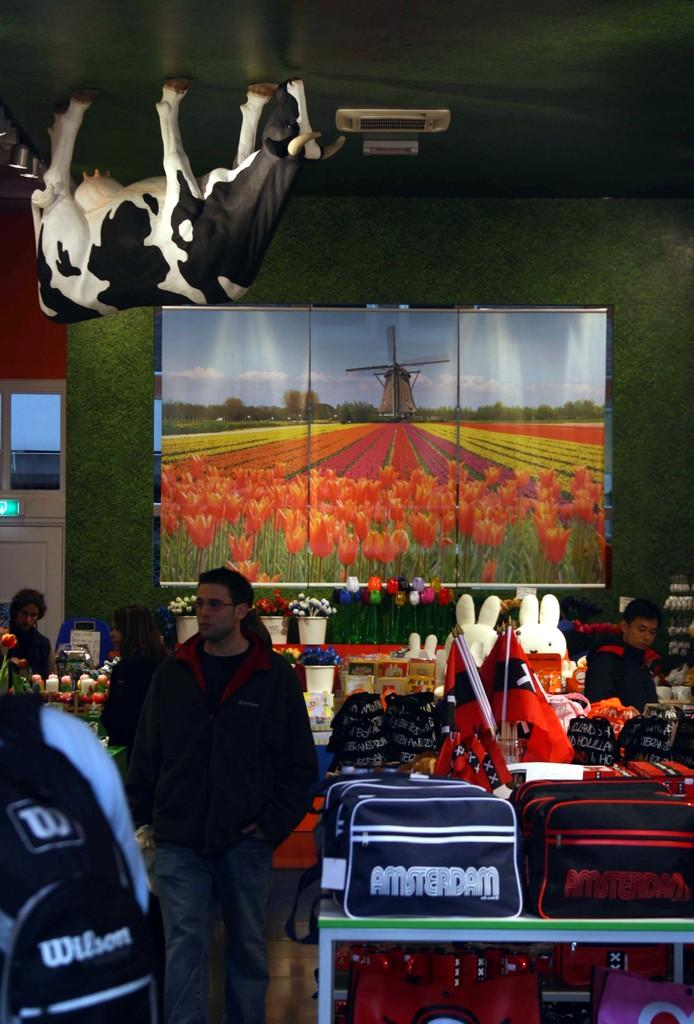What is happening in the center of the image? There are people standing in the center of the image. What can be seen in the background of the image? There is a wall, screens, bags, flags, and toys in the background of the image. What type of fact can be seen growing in the image? There is no fact growing in the image; the provided facts do not mention any plants or facts. 